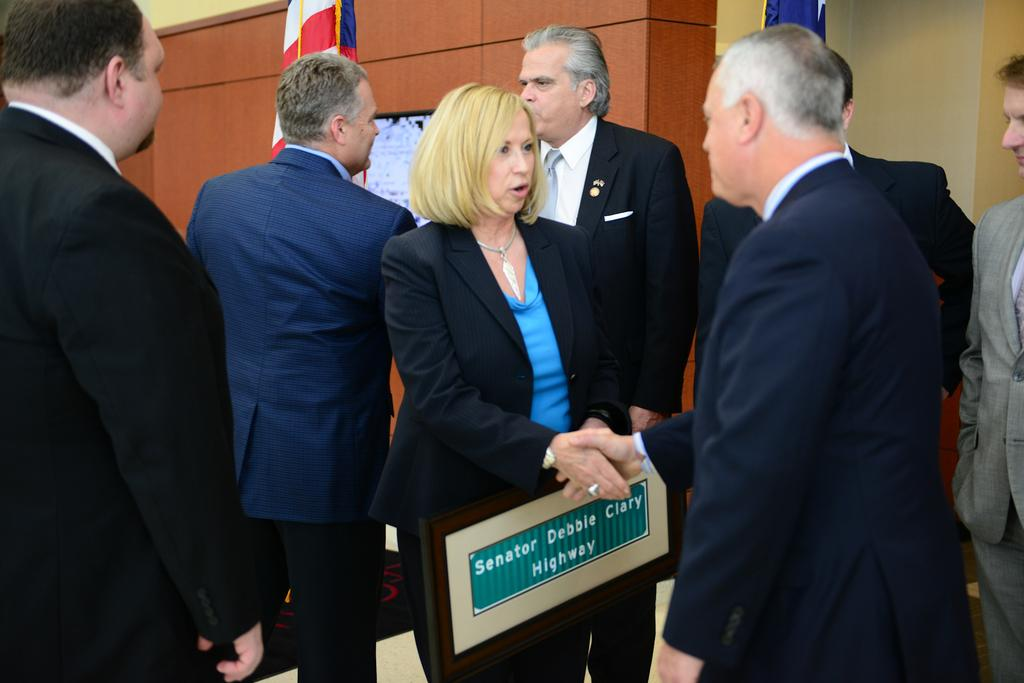How many people are in the image? There is a group of people in the image. What is the woman holding in the image? The woman is holding a name board. What can be seen in the background of the image? There are flags visible in the background. Can you describe the wooden wall in the background? There is an object on a wooden wall in the background. How does the sky feel when touched by the pot in the image? There is no pot or sky present in the image, so this question cannot be answered. 